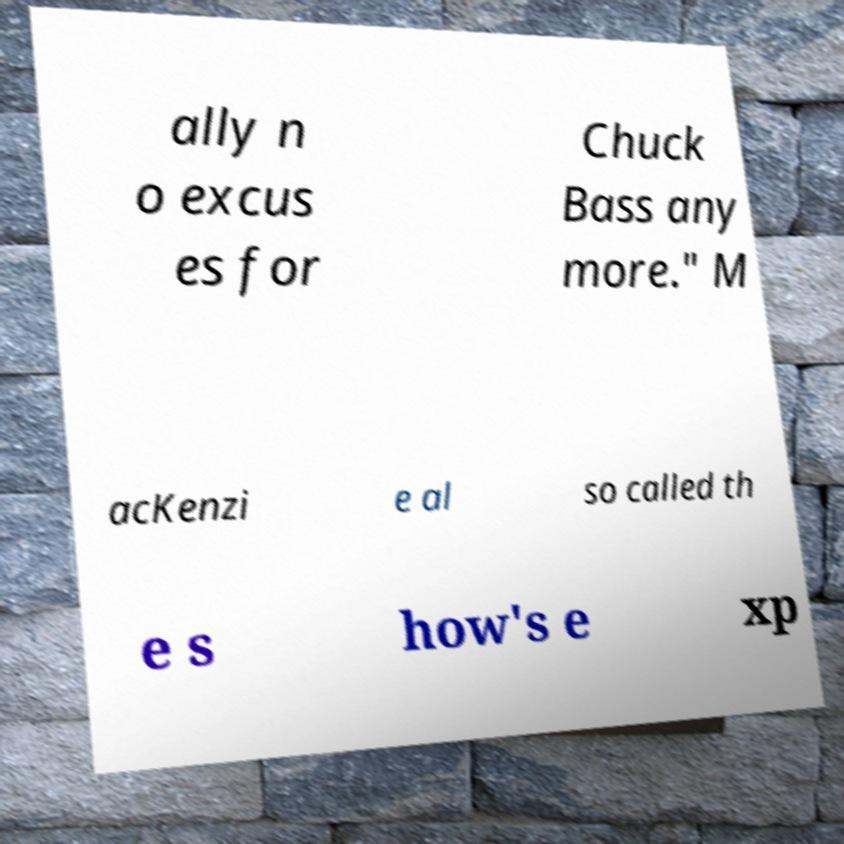I need the written content from this picture converted into text. Can you do that? ally n o excus es for Chuck Bass any more." M acKenzi e al so called th e s how's e xp 